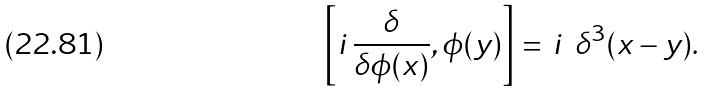<formula> <loc_0><loc_0><loc_500><loc_500>\left [ i \, \frac { \delta } { \delta \phi ( x ) } , \phi ( y ) \right ] = \, i \, \ \delta ^ { 3 } ( x - y ) .</formula> 